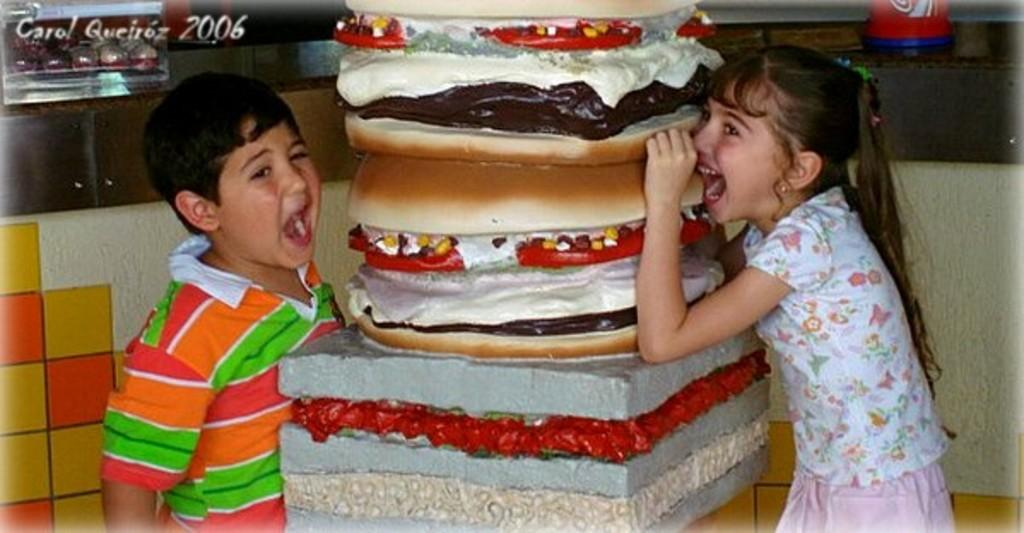How many kids are present in the image? There are two kids in the image. What is located in the center of the image? There is a depiction of a food item in the center of the image. Where can some text be found in the image? There is some text in the left side top corner of the image. How many teeth can be seen in the image? There are no teeth visible in the image. What type of boys are depicted in the image? The provided facts do not specify the gender of the kids in the image, so we cannot determine if they are boys or not. 